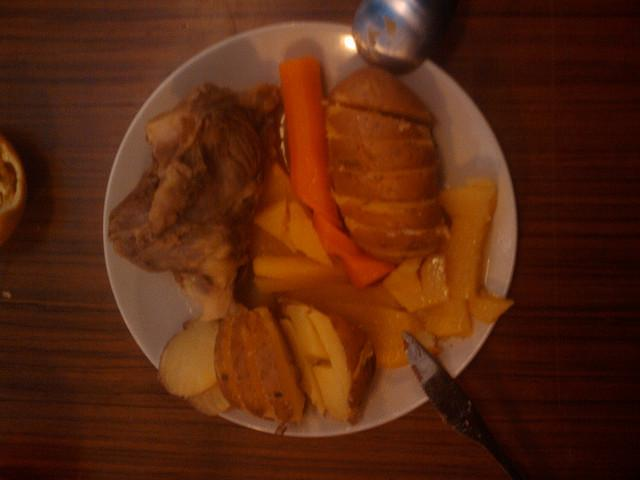What kind of vegetable is between the bread and the meat on top of the white plate?

Choices:
A) red
B) purple
C) orange
D) green orange 